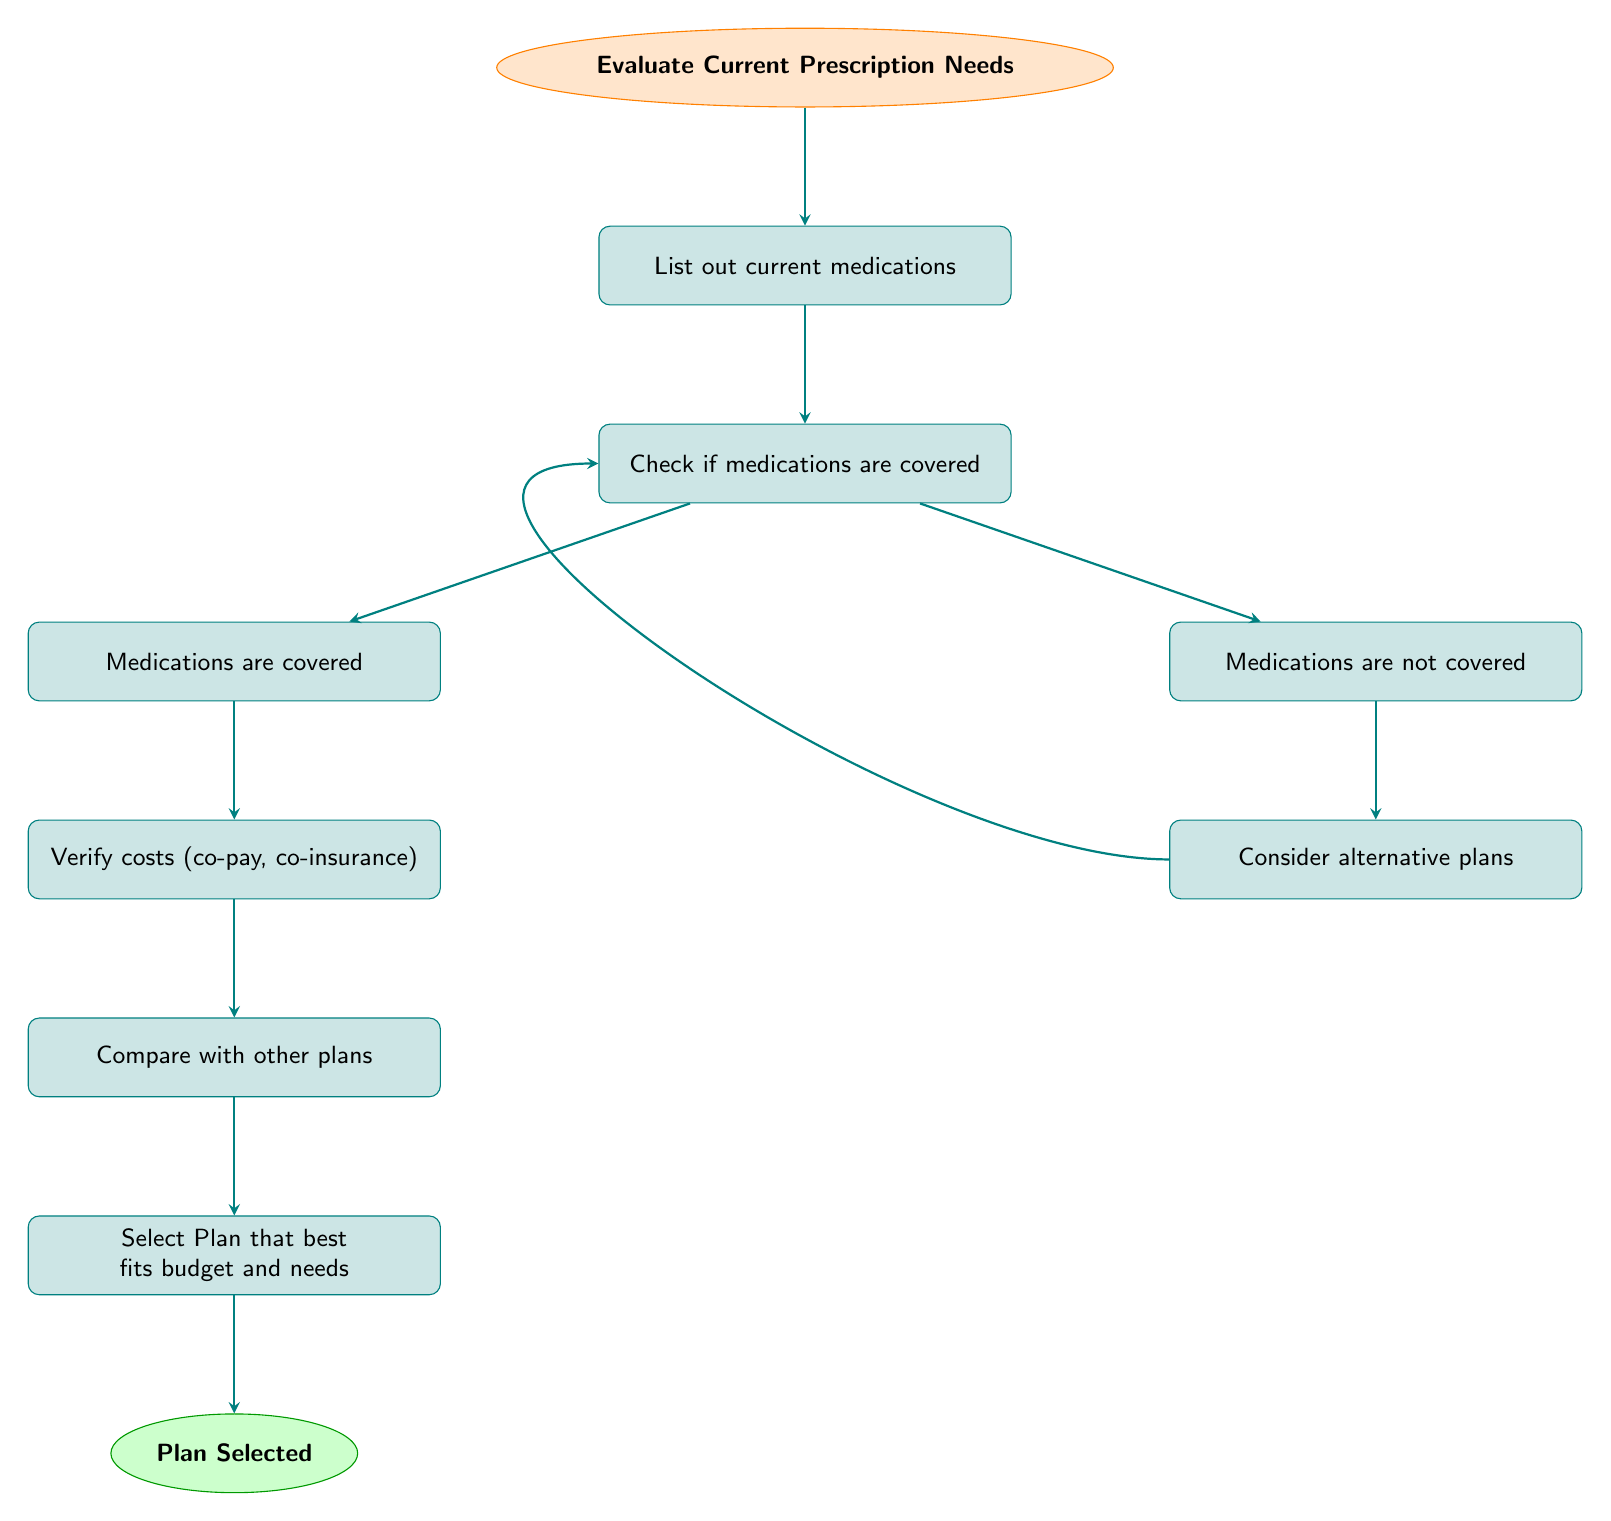What is the starting point in the flow chart? The starting point in the flow chart is labeled "Evaluate Current Prescription Needs", which is the first action a user should take in this decision-making process.
Answer: Evaluate Current Prescription Needs How many nodes are in the flow chart? By counting all nodes including the start and end nodes, there are a total of 8 nodes in the flow chart.
Answer: 8 What happens if medications are covered? If medications are covered, the next step is to "Verify costs (co-pay, co-insurance)", which is indicated by the flow proceeding to node 4a.
Answer: Verify costs (co-pay, co-insurance) What is the final action in the flow chart? The last action in the flow chart is to "Select Plan that best fits budget and needs", which leads directly to the end of the process.
Answer: Select Plan that best fits budget and needs What does the diagram suggest if medications are not covered? If medications are not covered, the flow chart suggests "Consider alternative plans", indicating that the user should look for different options.
Answer: Consider alternative plans What must you do after verifying costs? After verifying costs (co-pay, co-insurance), you must "Compare with other plans" to ensure that you are choosing the best option available based on costs.
Answer: Compare with other plans How does the process loop back when medications are not covered? The process loops back from "Consider alternative plans" to "Check if medications are covered", indicating that after considering alternatives, the user should verify coverage again.
Answer: Check if medications are covered What is the significance of the "Start" node? The "Start" node signals the initiation of the process, guiding the user to evaluate their current prescription needs before taking further actions.
Answer: Evaluate Current Prescription Needs 